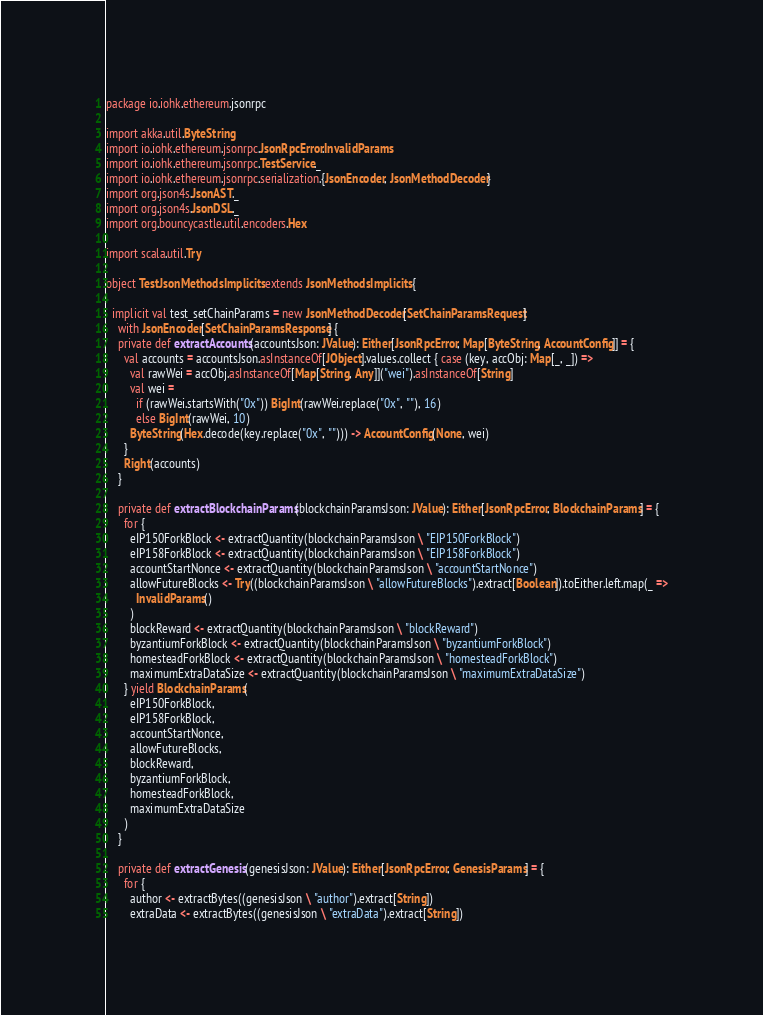<code> <loc_0><loc_0><loc_500><loc_500><_Scala_>package io.iohk.ethereum.jsonrpc

import akka.util.ByteString
import io.iohk.ethereum.jsonrpc.JsonRpcError.InvalidParams
import io.iohk.ethereum.jsonrpc.TestService._
import io.iohk.ethereum.jsonrpc.serialization.{JsonEncoder, JsonMethodDecoder}
import org.json4s.JsonAST._
import org.json4s.JsonDSL._
import org.bouncycastle.util.encoders.Hex

import scala.util.Try

object TestJsonMethodsImplicits extends JsonMethodsImplicits {

  implicit val test_setChainParams = new JsonMethodDecoder[SetChainParamsRequest]
    with JsonEncoder[SetChainParamsResponse] {
    private def extractAccounts(accountsJson: JValue): Either[JsonRpcError, Map[ByteString, AccountConfig]] = {
      val accounts = accountsJson.asInstanceOf[JObject].values.collect { case (key, accObj: Map[_, _]) =>
        val rawWei = accObj.asInstanceOf[Map[String, Any]]("wei").asInstanceOf[String]
        val wei =
          if (rawWei.startsWith("0x")) BigInt(rawWei.replace("0x", ""), 16)
          else BigInt(rawWei, 10)
        ByteString(Hex.decode(key.replace("0x", ""))) -> AccountConfig(None, wei)
      }
      Right(accounts)
    }

    private def extractBlockchainParams(blockchainParamsJson: JValue): Either[JsonRpcError, BlockchainParams] = {
      for {
        eIP150ForkBlock <- extractQuantity(blockchainParamsJson \ "EIP150ForkBlock")
        eIP158ForkBlock <- extractQuantity(blockchainParamsJson \ "EIP158ForkBlock")
        accountStartNonce <- extractQuantity(blockchainParamsJson \ "accountStartNonce")
        allowFutureBlocks <- Try((blockchainParamsJson \ "allowFutureBlocks").extract[Boolean]).toEither.left.map(_ =>
          InvalidParams()
        )
        blockReward <- extractQuantity(blockchainParamsJson \ "blockReward")
        byzantiumForkBlock <- extractQuantity(blockchainParamsJson \ "byzantiumForkBlock")
        homesteadForkBlock <- extractQuantity(blockchainParamsJson \ "homesteadForkBlock")
        maximumExtraDataSize <- extractQuantity(blockchainParamsJson \ "maximumExtraDataSize")
      } yield BlockchainParams(
        eIP150ForkBlock,
        eIP158ForkBlock,
        accountStartNonce,
        allowFutureBlocks,
        blockReward,
        byzantiumForkBlock,
        homesteadForkBlock,
        maximumExtraDataSize
      )
    }

    private def extractGenesis(genesisJson: JValue): Either[JsonRpcError, GenesisParams] = {
      for {
        author <- extractBytes((genesisJson \ "author").extract[String])
        extraData <- extractBytes((genesisJson \ "extraData").extract[String])</code> 